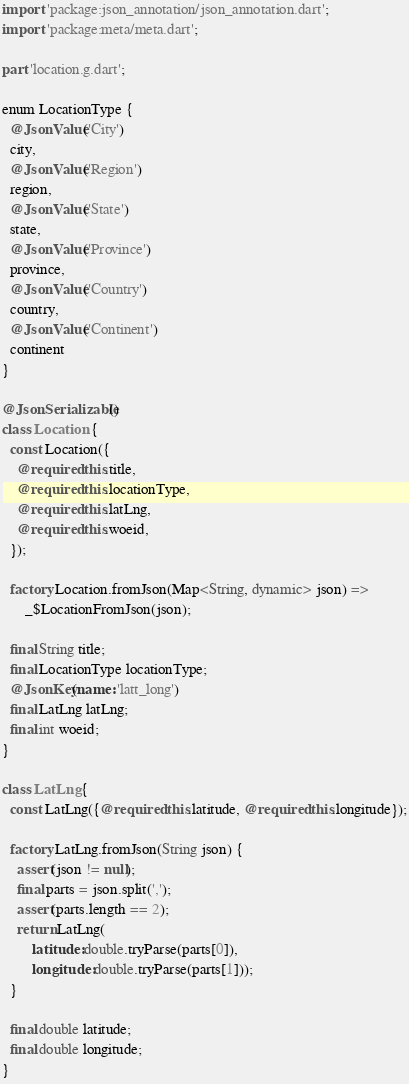<code> <loc_0><loc_0><loc_500><loc_500><_Dart_>import 'package:json_annotation/json_annotation.dart';
import 'package:meta/meta.dart';

part 'location.g.dart';

enum LocationType {
  @JsonValue('City')
  city,
  @JsonValue('Region')
  region,
  @JsonValue('State')
  state,
  @JsonValue('Province')
  province,
  @JsonValue('Country')
  country,
  @JsonValue('Continent')
  continent
}

@JsonSerializable()
class Location {
  const Location({
    @required this.title,
    @required this.locationType,
    @required this.latLng,
    @required this.woeid,
  });

  factory Location.fromJson(Map<String, dynamic> json) =>
      _$LocationFromJson(json);

  final String title;
  final LocationType locationType;
  @JsonKey(name: 'latt_long')
  final LatLng latLng;
  final int woeid;
}

class LatLng {
  const LatLng({@required this.latitude, @required this.longitude});

  factory LatLng.fromJson(String json) {
    assert(json != null);
    final parts = json.split(',');
    assert(parts.length == 2);
    return LatLng(
        latitude: double.tryParse(parts[0]),
        longitude: double.tryParse(parts[1]));
  }

  final double latitude;
  final double longitude;
}
</code> 